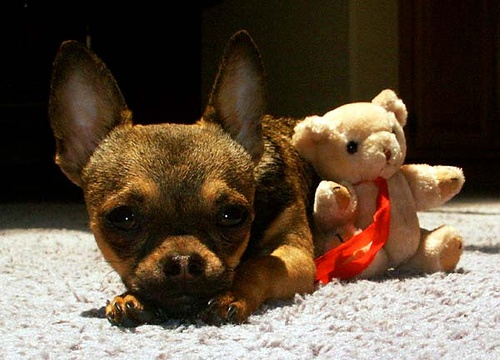Describe the objects in this image and their specific colors. I can see dog in black, maroon, and olive tones and teddy bear in black, maroon, brown, and khaki tones in this image. 